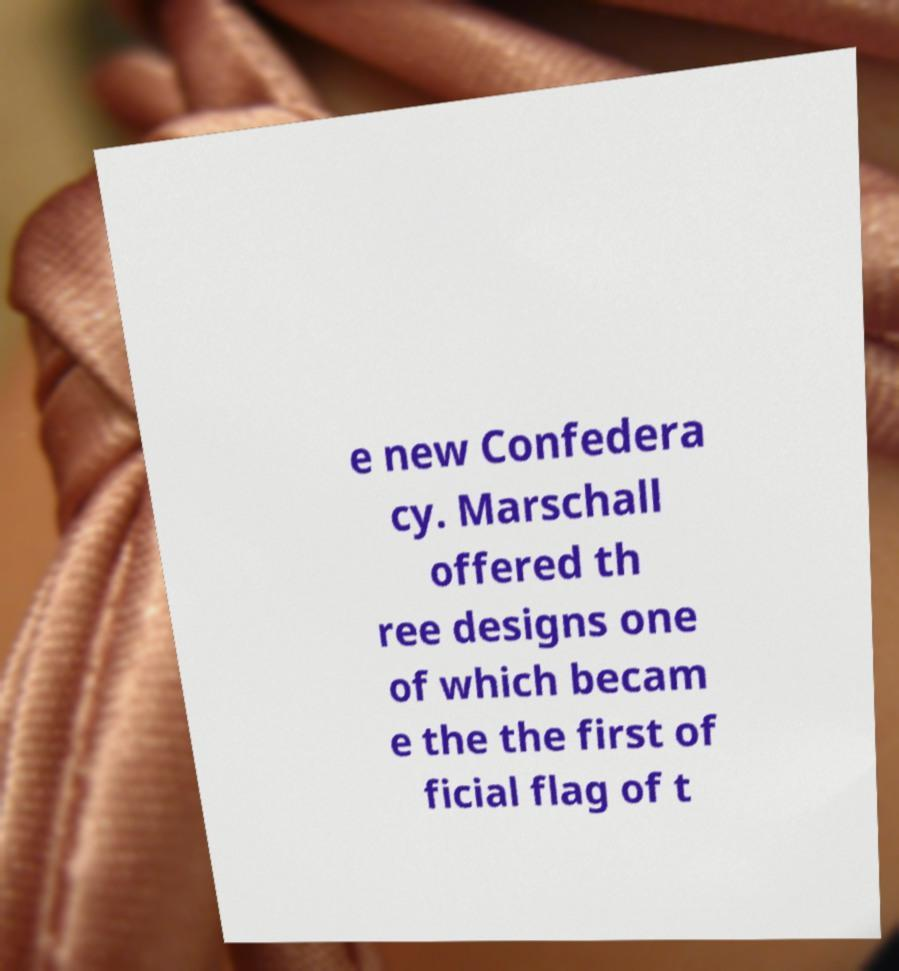What messages or text are displayed in this image? I need them in a readable, typed format. e new Confedera cy. Marschall offered th ree designs one of which becam e the the first of ficial flag of t 